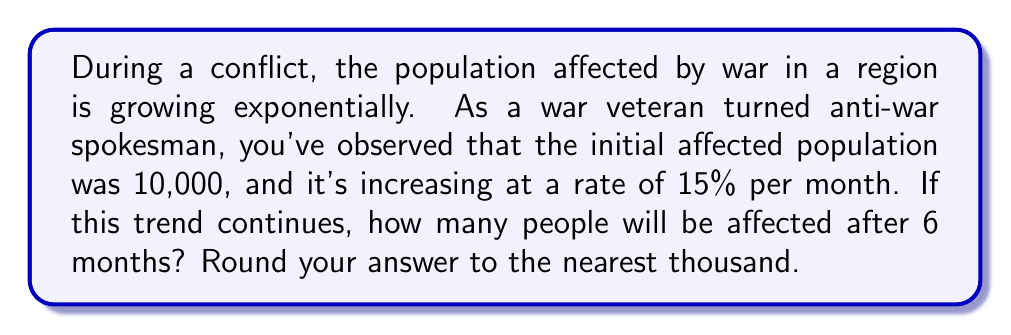Show me your answer to this math problem. To solve this problem, we'll use the exponential growth model:

$$P(t) = P_0 \cdot (1 + r)^t$$

Where:
$P(t)$ is the population at time $t$
$P_0$ is the initial population
$r$ is the growth rate (as a decimal)
$t$ is the time period

Given:
$P_0 = 10,000$
$r = 15\% = 0.15$
$t = 6$ months

Let's substitute these values into the equation:

$$P(6) = 10,000 \cdot (1 + 0.15)^6$$

Now, let's calculate step-by-step:

1) First, calculate $(1 + 0.15)^6$:
   $$(1.15)^6 \approx 2.3131$$

2) Multiply this by the initial population:
   $$10,000 \cdot 2.3131 = 23,131$$

3) Round to the nearest thousand:
   $$23,131 \approx 23,000$$

Therefore, after 6 months, approximately 23,000 people will be affected by the war if the current trend continues.
Answer: 23,000 people 